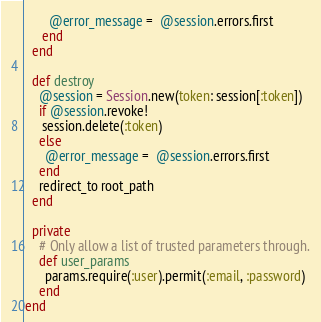<code> <loc_0><loc_0><loc_500><loc_500><_Ruby_>       @error_message =  @session.errors.first
     end
  end

  def destroy
    @session = Session.new(token: session[:token])
    if @session.revoke!
     session.delete(:token)
    else
      @error_message =  @session.errors.first
    end
    redirect_to root_path
  end

  private
    # Only allow a list of trusted parameters through.
    def user_params
      params.require(:user).permit(:email, :password)
    end
end
</code> 